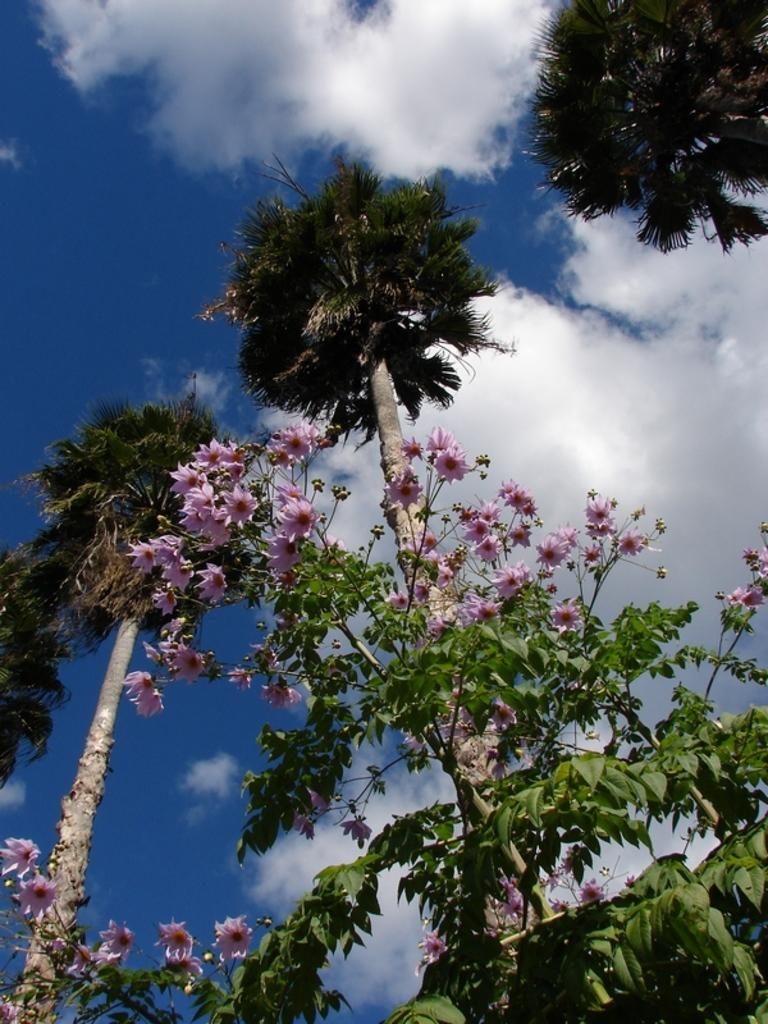What type of vegetation can be seen in the image? There are trees and plants in the image. What additional features can be observed on the plants? There are flowers on the plants. What is visible at the top of the image? The sky is visible at the top of the image. What can be seen in the sky? There are clouds in the sky. Can you compare the size of the bat to the flowers in the image? There is no bat present in the image, so it cannot be compared to the flowers. 